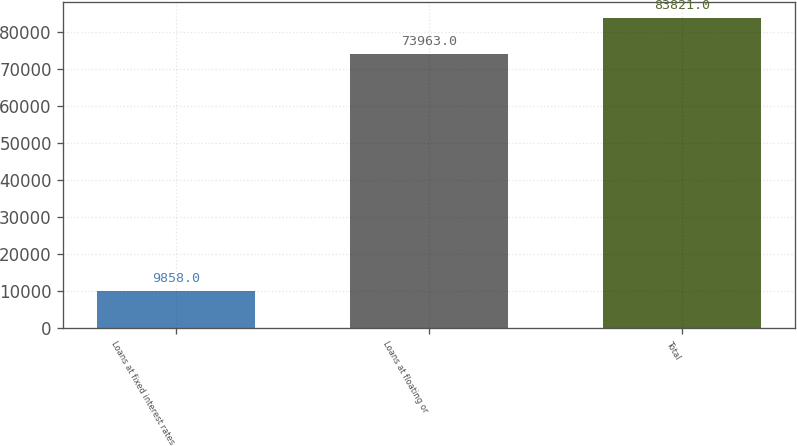Convert chart to OTSL. <chart><loc_0><loc_0><loc_500><loc_500><bar_chart><fcel>Loans at fixed interest rates<fcel>Loans at floating or<fcel>Total<nl><fcel>9858<fcel>73963<fcel>83821<nl></chart> 